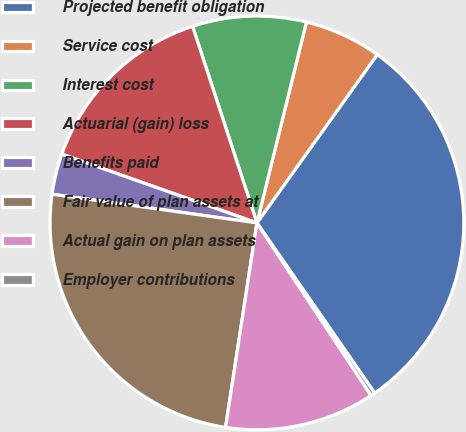Convert chart. <chart><loc_0><loc_0><loc_500><loc_500><pie_chart><fcel>Projected benefit obligation<fcel>Service cost<fcel>Interest cost<fcel>Actuarial (gain) loss<fcel>Benefits paid<fcel>Fair value of plan assets at<fcel>Actual gain on plan assets<fcel>Employer contributions<nl><fcel>30.49%<fcel>6.03%<fcel>8.88%<fcel>14.57%<fcel>3.18%<fcel>24.79%<fcel>11.73%<fcel>0.33%<nl></chart> 